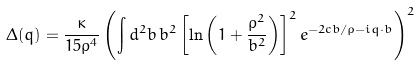Convert formula to latex. <formula><loc_0><loc_0><loc_500><loc_500>\Delta ( q ) = \frac { \kappa } { 1 5 \rho ^ { 4 } } \left ( \int d ^ { 2 } b \, { b ^ { 2 } \left [ \ln \left ( 1 + \frac { \rho ^ { 2 } } { b ^ { 2 } } \right ) \right ] ^ { 2 } e ^ { - 2 c b / \rho - i q \cdot b } } \right ) ^ { 2 }</formula> 